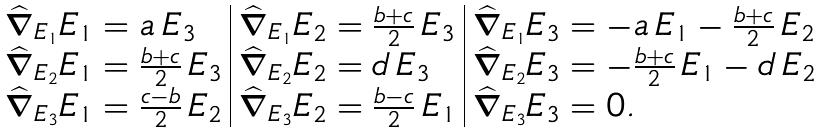Convert formula to latex. <formula><loc_0><loc_0><loc_500><loc_500>\begin{array} { l | l | l } \widehat { \nabla } _ { E _ { 1 } } E _ { 1 } = a \, E _ { 3 } & \widehat { \nabla } _ { E _ { 1 } } E _ { 2 } = \frac { b + c } { 2 } \, E _ { 3 } & \widehat { \nabla } _ { E _ { 1 } } E _ { 3 } = - a \, E _ { 1 } - \frac { b + c } { 2 } \, E _ { 2 } \\ \widehat { \nabla } _ { E _ { 2 } } E _ { 1 } = \frac { b + c } { 2 } \, E _ { 3 } & \widehat { \nabla } _ { E _ { 2 } } E _ { 2 } = d \, E _ { 3 } & \widehat { \nabla } _ { E _ { 2 } } E _ { 3 } = - \frac { b + c } { 2 } \, E _ { 1 } - d \, E _ { 2 } \\ \widehat { \nabla } _ { E _ { 3 } } E _ { 1 } = \frac { c - b } { 2 } \, E _ { 2 } & \widehat { \nabla } _ { E _ { 3 } } E _ { 2 } = \frac { b - c } { 2 } \, E _ { 1 } & \widehat { \nabla } _ { E _ { 3 } } E _ { 3 } = 0 . \end{array}</formula> 